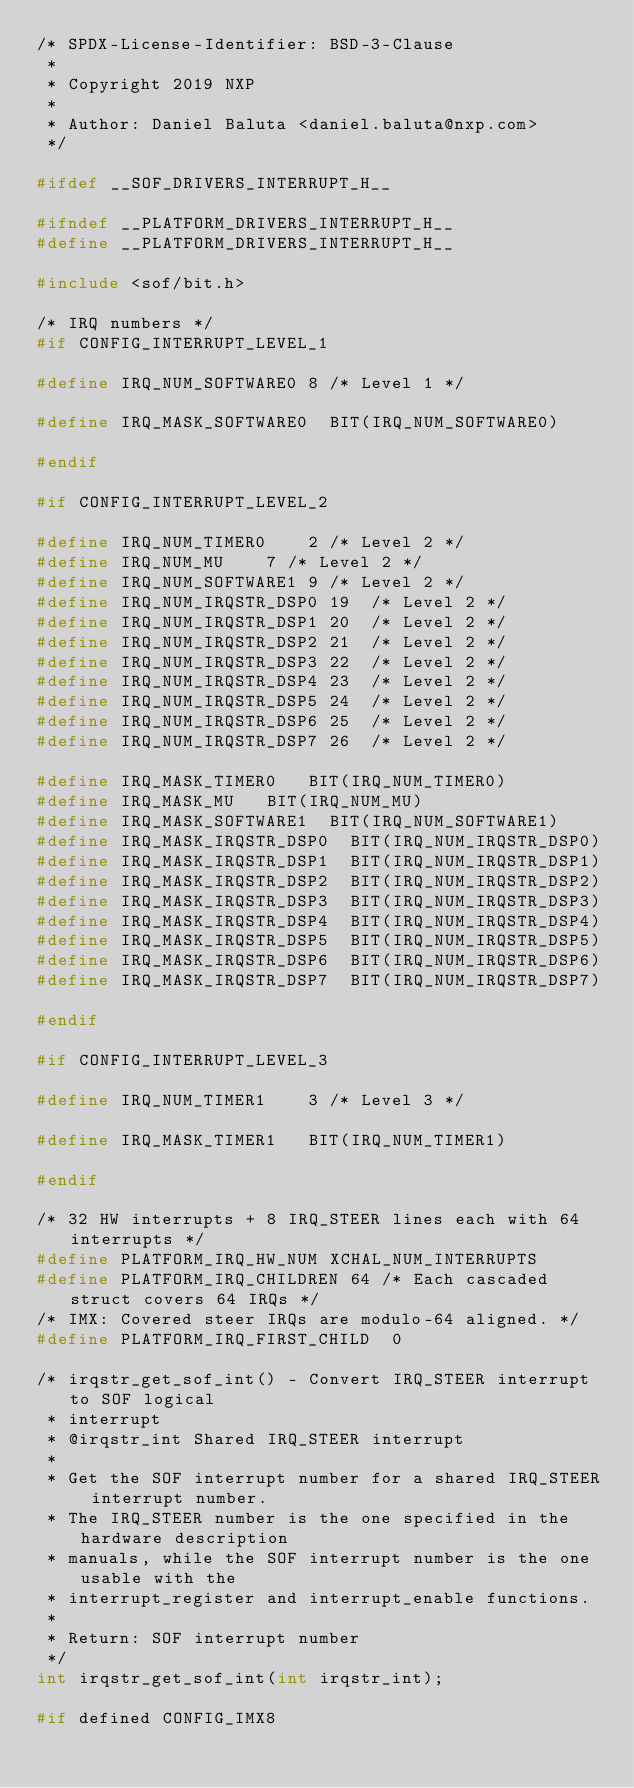<code> <loc_0><loc_0><loc_500><loc_500><_C_>/* SPDX-License-Identifier: BSD-3-Clause
 *
 * Copyright 2019 NXP
 *
 * Author: Daniel Baluta <daniel.baluta@nxp.com>
 */

#ifdef __SOF_DRIVERS_INTERRUPT_H__

#ifndef __PLATFORM_DRIVERS_INTERRUPT_H__
#define __PLATFORM_DRIVERS_INTERRUPT_H__

#include <sof/bit.h>

/* IRQ numbers */
#if CONFIG_INTERRUPT_LEVEL_1

#define IRQ_NUM_SOFTWARE0	8	/* Level 1 */

#define IRQ_MASK_SOFTWARE0	BIT(IRQ_NUM_SOFTWARE0)

#endif

#if CONFIG_INTERRUPT_LEVEL_2

#define IRQ_NUM_TIMER0		2	/* Level 2 */
#define IRQ_NUM_MU		7	/* Level 2 */
#define IRQ_NUM_SOFTWARE1	9	/* Level 2 */
#define IRQ_NUM_IRQSTR_DSP0	19	/* Level 2 */
#define IRQ_NUM_IRQSTR_DSP1	20	/* Level 2 */
#define IRQ_NUM_IRQSTR_DSP2	21	/* Level 2 */
#define IRQ_NUM_IRQSTR_DSP3	22	/* Level 2 */
#define IRQ_NUM_IRQSTR_DSP4	23	/* Level 2 */
#define IRQ_NUM_IRQSTR_DSP5	24	/* Level 2 */
#define IRQ_NUM_IRQSTR_DSP6	25	/* Level 2 */
#define IRQ_NUM_IRQSTR_DSP7	26	/* Level 2 */

#define IRQ_MASK_TIMER0		BIT(IRQ_NUM_TIMER0)
#define IRQ_MASK_MU		BIT(IRQ_NUM_MU)
#define IRQ_MASK_SOFTWARE1	BIT(IRQ_NUM_SOFTWARE1)
#define IRQ_MASK_IRQSTR_DSP0	BIT(IRQ_NUM_IRQSTR_DSP0)
#define IRQ_MASK_IRQSTR_DSP1	BIT(IRQ_NUM_IRQSTR_DSP1)
#define IRQ_MASK_IRQSTR_DSP2	BIT(IRQ_NUM_IRQSTR_DSP2)
#define IRQ_MASK_IRQSTR_DSP3	BIT(IRQ_NUM_IRQSTR_DSP3)
#define IRQ_MASK_IRQSTR_DSP4	BIT(IRQ_NUM_IRQSTR_DSP4)
#define IRQ_MASK_IRQSTR_DSP5	BIT(IRQ_NUM_IRQSTR_DSP5)
#define IRQ_MASK_IRQSTR_DSP6	BIT(IRQ_NUM_IRQSTR_DSP6)
#define IRQ_MASK_IRQSTR_DSP7	BIT(IRQ_NUM_IRQSTR_DSP7)

#endif

#if CONFIG_INTERRUPT_LEVEL_3

#define IRQ_NUM_TIMER1		3	/* Level 3 */

#define IRQ_MASK_TIMER1		BIT(IRQ_NUM_TIMER1)

#endif

/* 32 HW interrupts + 8 IRQ_STEER lines each with 64 interrupts */
#define PLATFORM_IRQ_HW_NUM	XCHAL_NUM_INTERRUPTS
#define PLATFORM_IRQ_CHILDREN	64 /* Each cascaded struct covers 64 IRQs */
/* IMX: Covered steer IRQs are modulo-64 aligned. */
#define PLATFORM_IRQ_FIRST_CHILD  0

/* irqstr_get_sof_int() - Convert IRQ_STEER interrupt to SOF logical
 * interrupt
 * @irqstr_int Shared IRQ_STEER interrupt
 *
 * Get the SOF interrupt number for a shared IRQ_STEER interrupt number.
 * The IRQ_STEER number is the one specified in the hardware description
 * manuals, while the SOF interrupt number is the one usable with the
 * interrupt_register and interrupt_enable functions.
 *
 * Return: SOF interrupt number
 */
int irqstr_get_sof_int(int irqstr_int);

#if defined CONFIG_IMX8</code> 